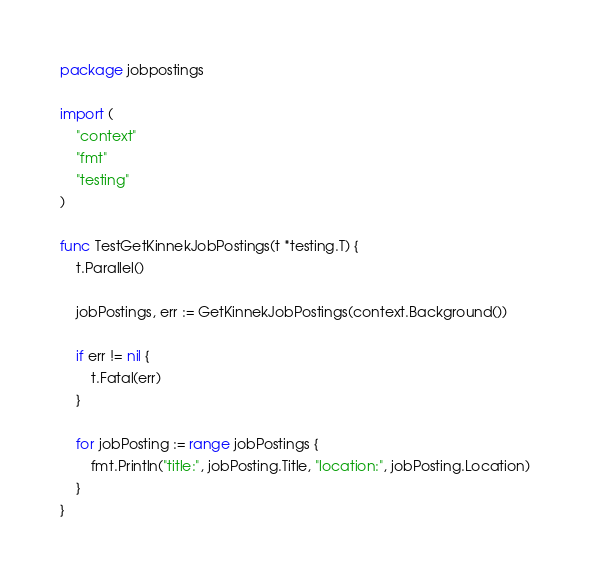Convert code to text. <code><loc_0><loc_0><loc_500><loc_500><_Go_>package jobpostings

import (
	"context"
	"fmt"
	"testing"
)

func TestGetKinnekJobPostings(t *testing.T) {
	t.Parallel()

	jobPostings, err := GetKinnekJobPostings(context.Background())

	if err != nil {
		t.Fatal(err)
	}

	for jobPosting := range jobPostings {
		fmt.Println("title:", jobPosting.Title, "location:", jobPosting.Location)
	}
}
</code> 